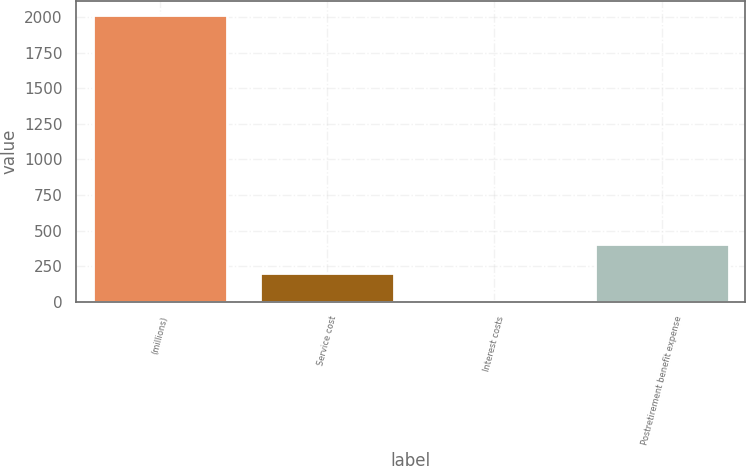<chart> <loc_0><loc_0><loc_500><loc_500><bar_chart><fcel>(millions)<fcel>Service cost<fcel>Interest costs<fcel>Postretirement benefit expense<nl><fcel>2013<fcel>204.99<fcel>4.1<fcel>405.88<nl></chart> 